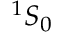<formula> <loc_0><loc_0><loc_500><loc_500>^ { 1 } S _ { 0 }</formula> 